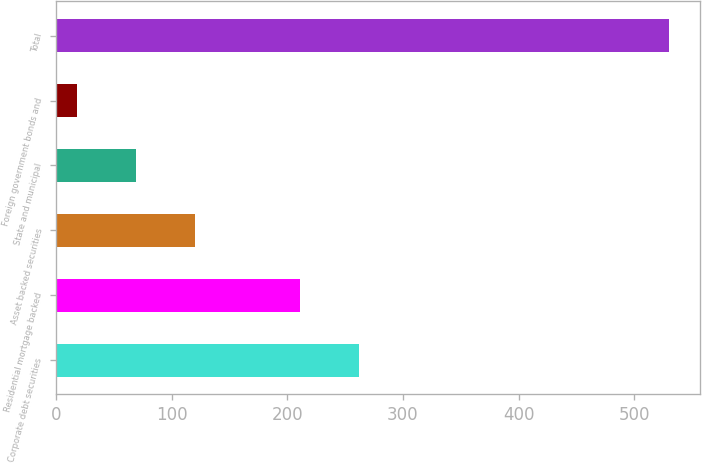Convert chart to OTSL. <chart><loc_0><loc_0><loc_500><loc_500><bar_chart><fcel>Corporate debt securities<fcel>Residential mortgage backed<fcel>Asset backed securities<fcel>State and municipal<fcel>Foreign government bonds and<fcel>Total<nl><fcel>262.2<fcel>211<fcel>120.4<fcel>69.2<fcel>18<fcel>530<nl></chart> 